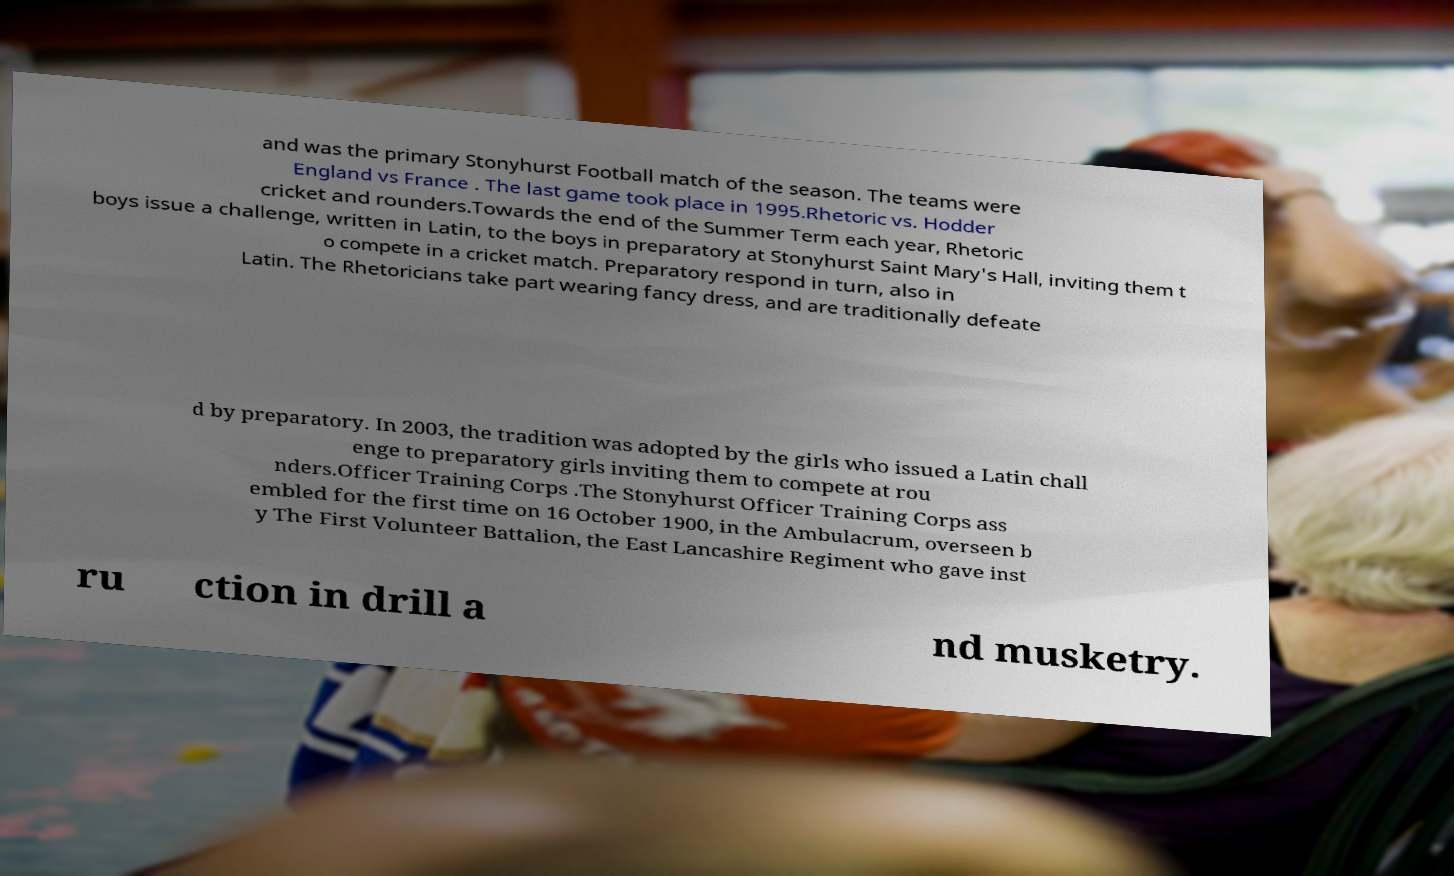Please identify and transcribe the text found in this image. and was the primary Stonyhurst Football match of the season. The teams were England vs France . The last game took place in 1995.Rhetoric vs. Hodder cricket and rounders.Towards the end of the Summer Term each year, Rhetoric boys issue a challenge, written in Latin, to the boys in preparatory at Stonyhurst Saint Mary's Hall, inviting them t o compete in a cricket match. Preparatory respond in turn, also in Latin. The Rhetoricians take part wearing fancy dress, and are traditionally defeate d by preparatory. In 2003, the tradition was adopted by the girls who issued a Latin chall enge to preparatory girls inviting them to compete at rou nders.Officer Training Corps .The Stonyhurst Officer Training Corps ass embled for the first time on 16 October 1900, in the Ambulacrum, overseen b y The First Volunteer Battalion, the East Lancashire Regiment who gave inst ru ction in drill a nd musketry. 